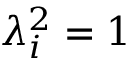Convert formula to latex. <formula><loc_0><loc_0><loc_500><loc_500>\lambda _ { i } ^ { 2 } = 1</formula> 